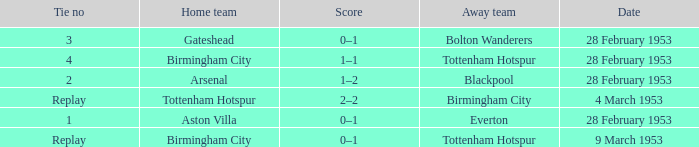Which Score has a Date of 28 february 1953, and a Tie no of 3? 0–1. 